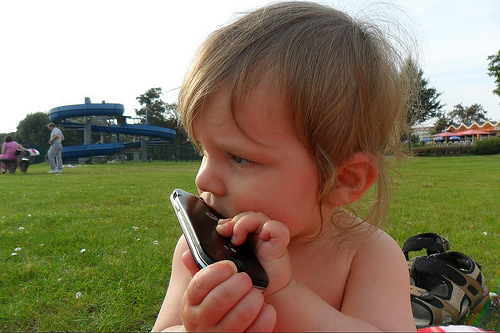How many people are in this picture? In the picture, there is one child visible, holding a mobile phone and appearing to be engaged with it. The child's attention is captivated by the device, reflecting a glimpse into the intersection of youth and technology. There's no clear indication of other people in the immediate shot, although it's possible others are present but outside the camera's frame. 